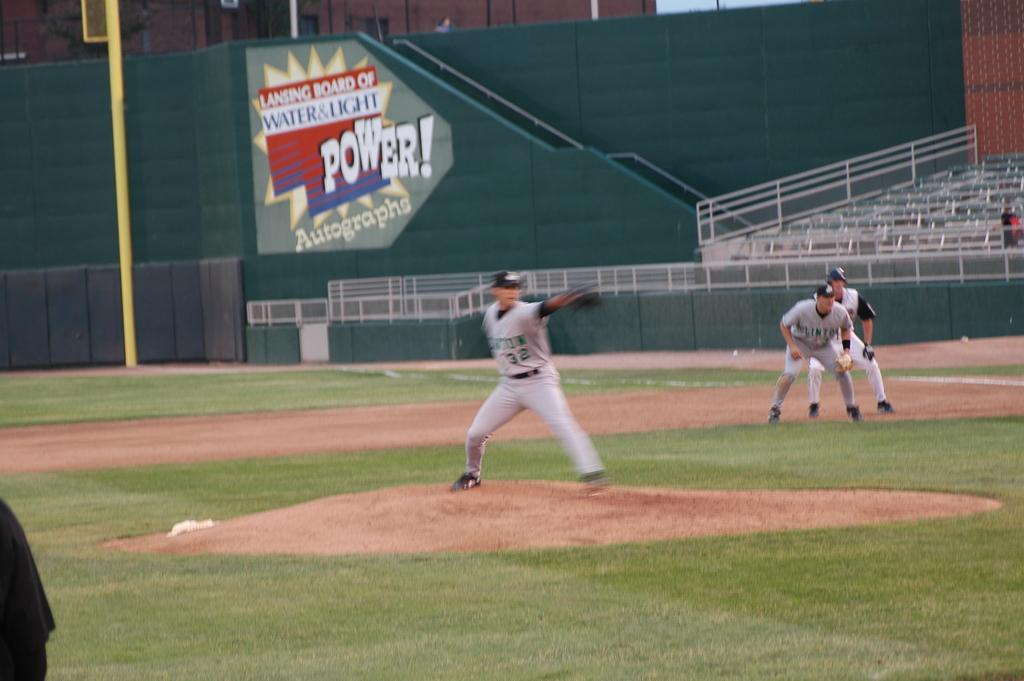<image>
Provide a brief description of the given image. A pitcher, wearing jersey number 32, gets ready to throw the ball. 